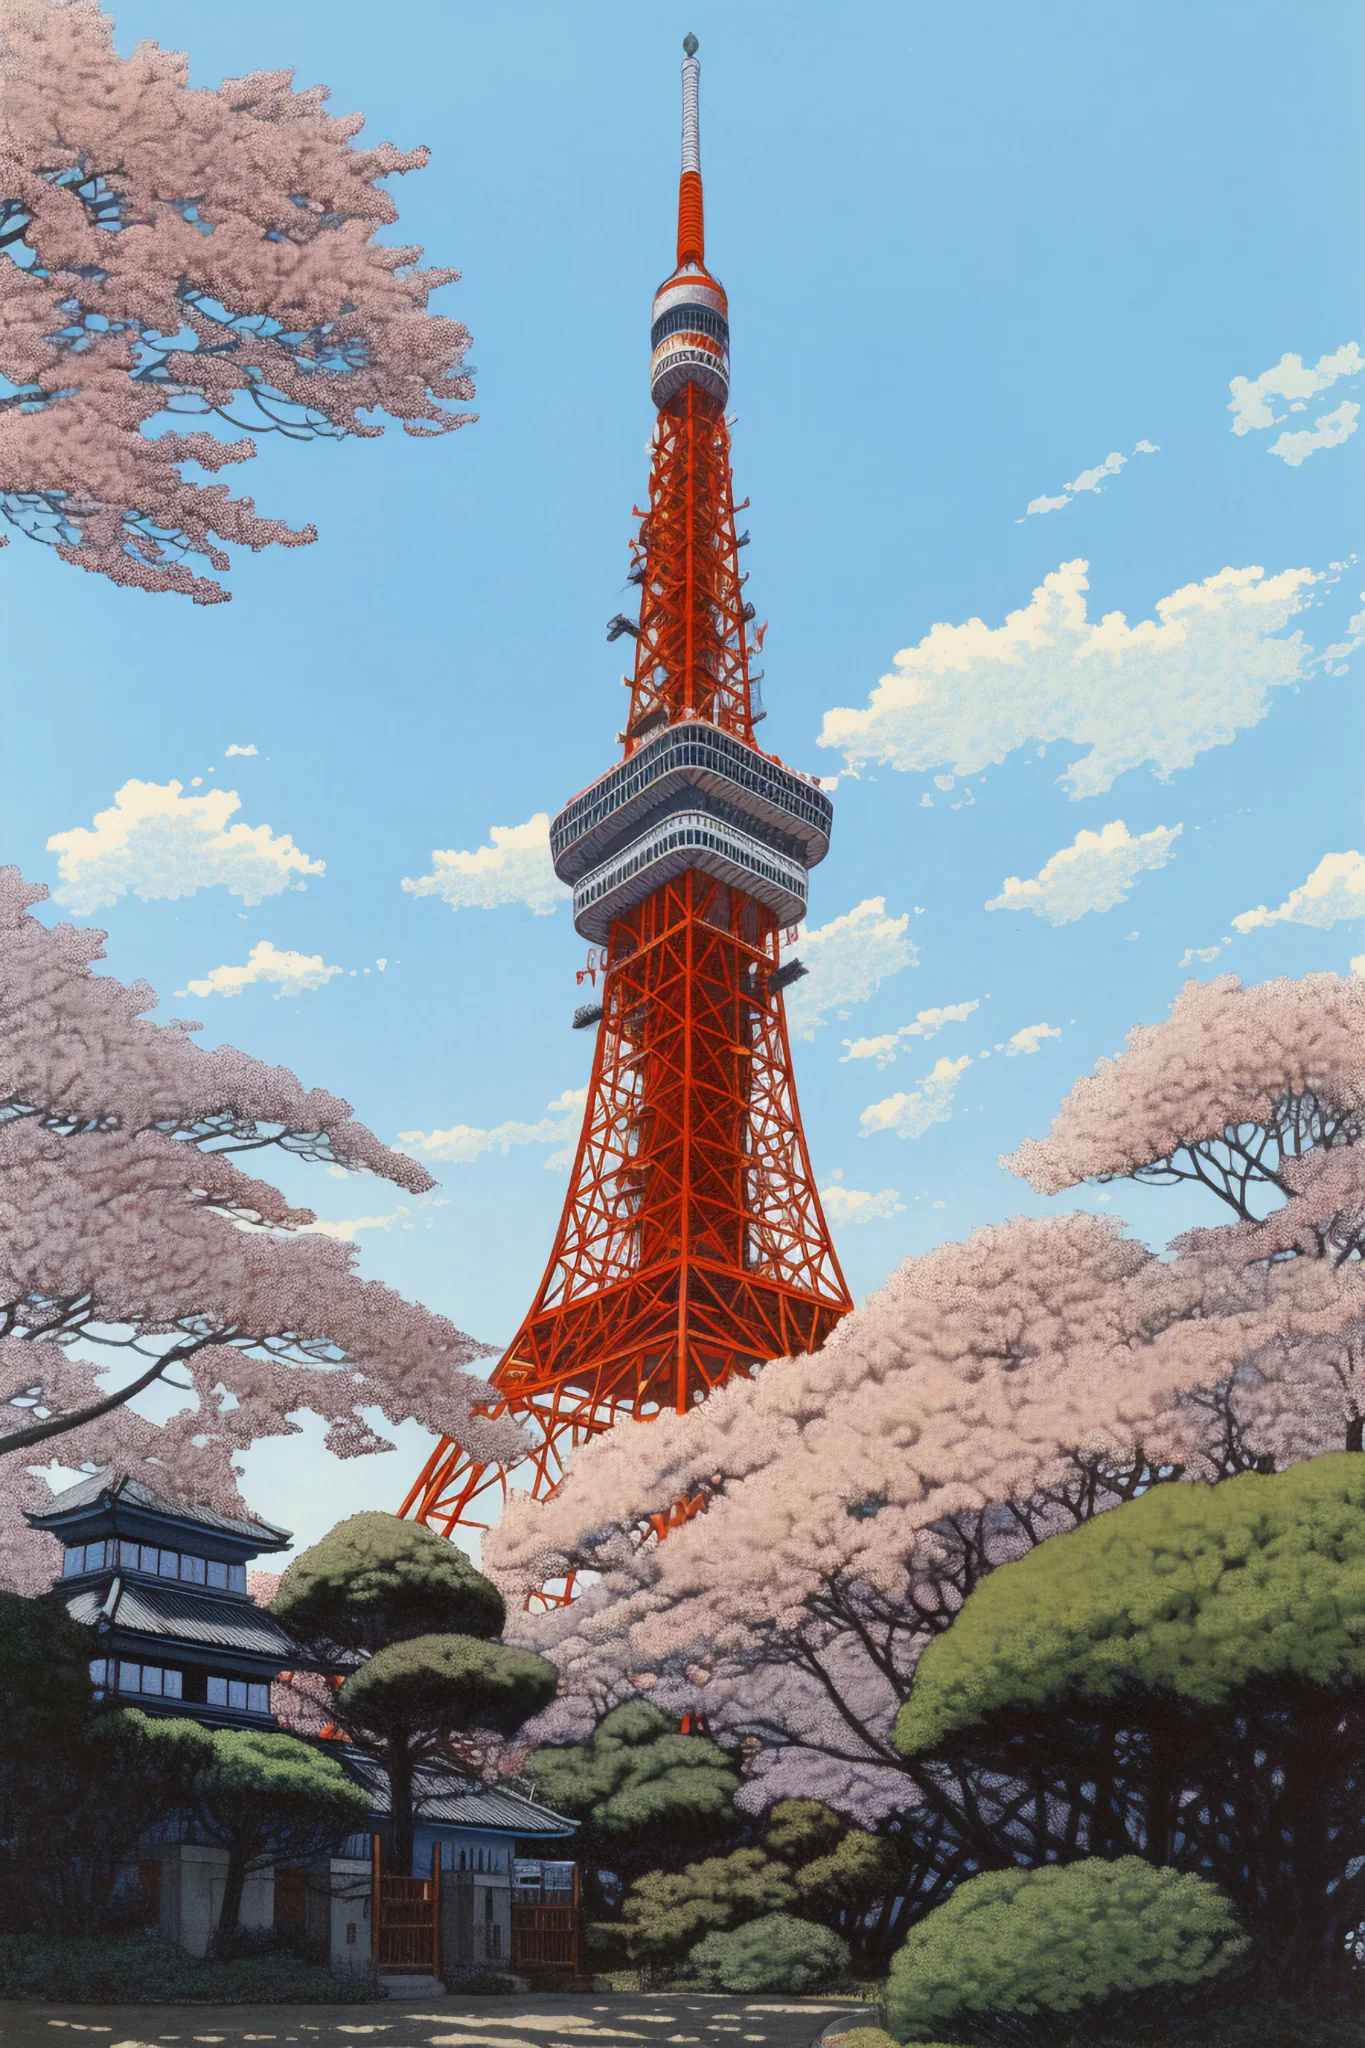How do the architectural styles in the image contrast with each other? The architectural juxtaposition in the image reflects Japan's unique blend of tradition and modernity. Tokyo Tower, with its modern steel lattice and vibrant color, symbolizes progress and the forward-looking ethos of post-war Japan. Contrastingly, the traditional Japanese building nestled among the trees represents historical architectural styles that emphasize wooden structures and sliding doors, designed to blend seamlessly with the natural surroundings. This contrast not only highlights the diverse architectural palate of Tokyo but also the cultural synthesis seen across Japan. 